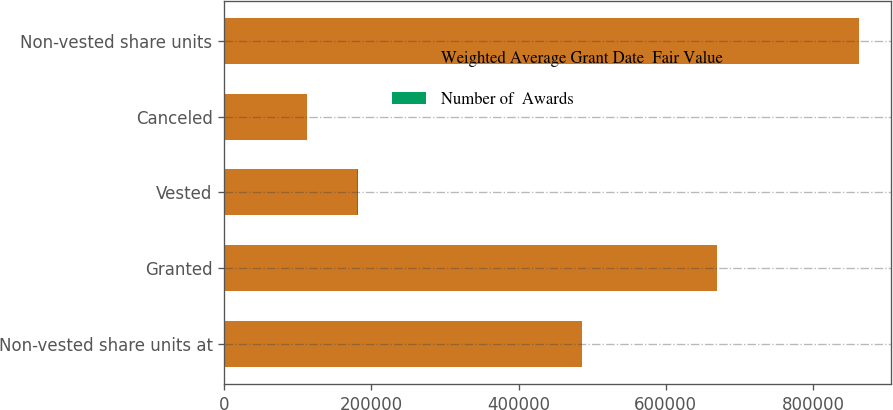<chart> <loc_0><loc_0><loc_500><loc_500><stacked_bar_chart><ecel><fcel>Non-vested share units at<fcel>Granted<fcel>Vested<fcel>Canceled<fcel>Non-vested share units<nl><fcel>Weighted Average Grant Date  Fair Value<fcel>486510<fcel>669538<fcel>181022<fcel>112292<fcel>862734<nl><fcel>Number of  Awards<fcel>44.43<fcel>33.79<fcel>43.3<fcel>45.59<fcel>36.24<nl></chart> 